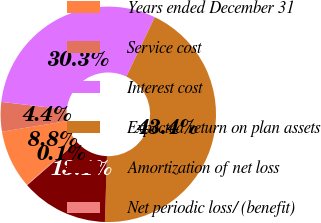Convert chart. <chart><loc_0><loc_0><loc_500><loc_500><pie_chart><fcel>Years ended December 31<fcel>Service cost<fcel>Interest cost<fcel>Expected return on plan assets<fcel>Amortization of net loss<fcel>Net periodic loss/ (benefit)<nl><fcel>8.75%<fcel>4.42%<fcel>30.26%<fcel>43.4%<fcel>13.08%<fcel>0.09%<nl></chart> 